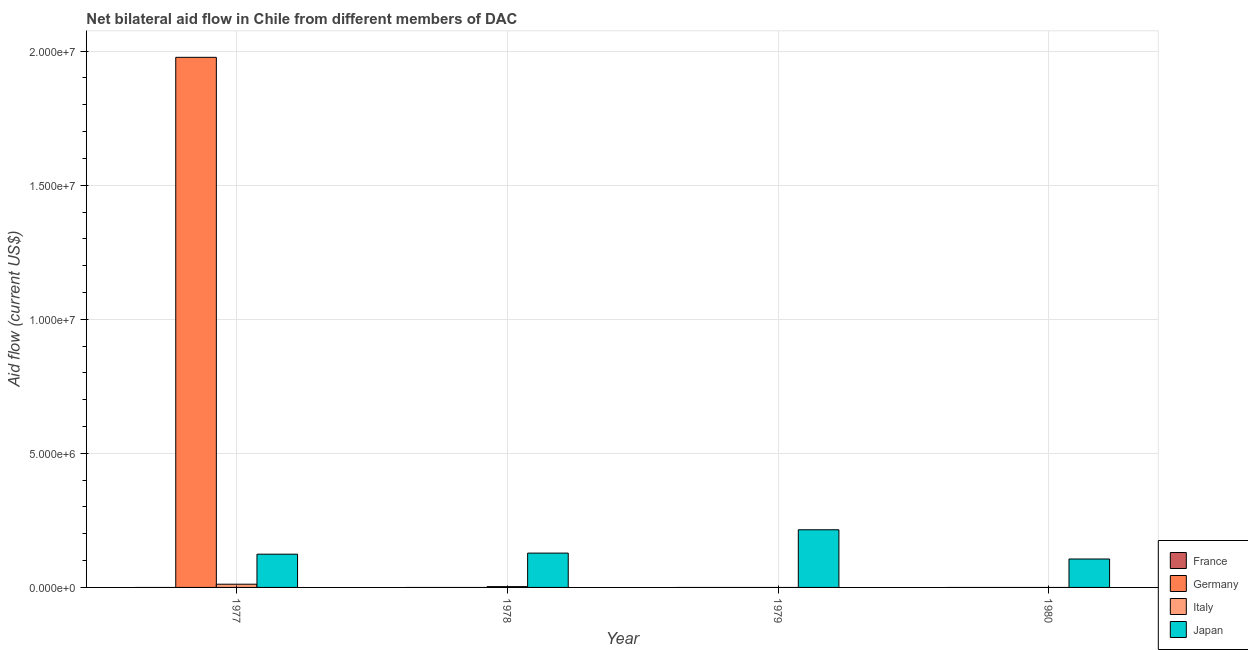How many different coloured bars are there?
Your answer should be compact. 3. Are the number of bars on each tick of the X-axis equal?
Make the answer very short. No. How many bars are there on the 1st tick from the left?
Keep it short and to the point. 3. In how many cases, is the number of bars for a given year not equal to the number of legend labels?
Your response must be concise. 4. What is the amount of aid given by italy in 1978?
Provide a succinct answer. 3.00e+04. Across all years, what is the maximum amount of aid given by italy?
Provide a short and direct response. 1.20e+05. Across all years, what is the minimum amount of aid given by germany?
Keep it short and to the point. 0. In which year was the amount of aid given by germany maximum?
Offer a terse response. 1977. What is the total amount of aid given by italy in the graph?
Make the answer very short. 1.50e+05. What is the difference between the amount of aid given by japan in 1979 and that in 1980?
Your answer should be very brief. 1.09e+06. What is the difference between the amount of aid given by france in 1977 and the amount of aid given by japan in 1978?
Ensure brevity in your answer.  0. What is the average amount of aid given by italy per year?
Ensure brevity in your answer.  3.75e+04. In how many years, is the amount of aid given by france greater than 14000000 US$?
Offer a very short reply. 0. What is the ratio of the amount of aid given by japan in 1978 to that in 1980?
Provide a succinct answer. 1.21. What is the difference between the highest and the second highest amount of aid given by japan?
Offer a very short reply. 8.70e+05. What is the difference between the highest and the lowest amount of aid given by italy?
Give a very brief answer. 1.20e+05. Is it the case that in every year, the sum of the amount of aid given by france and amount of aid given by germany is greater than the amount of aid given by italy?
Provide a short and direct response. No. How many bars are there?
Your answer should be very brief. 7. Are all the bars in the graph horizontal?
Provide a short and direct response. No. What is the difference between two consecutive major ticks on the Y-axis?
Give a very brief answer. 5.00e+06. Does the graph contain grids?
Your response must be concise. Yes. Where does the legend appear in the graph?
Your response must be concise. Bottom right. How many legend labels are there?
Your answer should be very brief. 4. How are the legend labels stacked?
Make the answer very short. Vertical. What is the title of the graph?
Ensure brevity in your answer.  Net bilateral aid flow in Chile from different members of DAC. Does "Portugal" appear as one of the legend labels in the graph?
Make the answer very short. No. What is the label or title of the X-axis?
Offer a very short reply. Year. What is the label or title of the Y-axis?
Make the answer very short. Aid flow (current US$). What is the Aid flow (current US$) in Germany in 1977?
Offer a terse response. 1.98e+07. What is the Aid flow (current US$) of Japan in 1977?
Your answer should be very brief. 1.24e+06. What is the Aid flow (current US$) in France in 1978?
Keep it short and to the point. 0. What is the Aid flow (current US$) of Italy in 1978?
Offer a terse response. 3.00e+04. What is the Aid flow (current US$) in Japan in 1978?
Your response must be concise. 1.28e+06. What is the Aid flow (current US$) in Germany in 1979?
Ensure brevity in your answer.  0. What is the Aid flow (current US$) in Japan in 1979?
Give a very brief answer. 2.15e+06. What is the Aid flow (current US$) in France in 1980?
Offer a terse response. 0. What is the Aid flow (current US$) in Germany in 1980?
Offer a terse response. 0. What is the Aid flow (current US$) in Japan in 1980?
Keep it short and to the point. 1.06e+06. Across all years, what is the maximum Aid flow (current US$) in Germany?
Your answer should be very brief. 1.98e+07. Across all years, what is the maximum Aid flow (current US$) of Japan?
Offer a very short reply. 2.15e+06. Across all years, what is the minimum Aid flow (current US$) in Italy?
Make the answer very short. 0. Across all years, what is the minimum Aid flow (current US$) in Japan?
Offer a terse response. 1.06e+06. What is the total Aid flow (current US$) in France in the graph?
Provide a short and direct response. 0. What is the total Aid flow (current US$) in Germany in the graph?
Make the answer very short. 1.98e+07. What is the total Aid flow (current US$) of Italy in the graph?
Your response must be concise. 1.50e+05. What is the total Aid flow (current US$) of Japan in the graph?
Offer a terse response. 5.73e+06. What is the difference between the Aid flow (current US$) of Italy in 1977 and that in 1978?
Your response must be concise. 9.00e+04. What is the difference between the Aid flow (current US$) in Japan in 1977 and that in 1979?
Provide a short and direct response. -9.10e+05. What is the difference between the Aid flow (current US$) of Japan in 1977 and that in 1980?
Your answer should be compact. 1.80e+05. What is the difference between the Aid flow (current US$) of Japan in 1978 and that in 1979?
Make the answer very short. -8.70e+05. What is the difference between the Aid flow (current US$) in Japan in 1979 and that in 1980?
Make the answer very short. 1.09e+06. What is the difference between the Aid flow (current US$) of Germany in 1977 and the Aid flow (current US$) of Italy in 1978?
Keep it short and to the point. 1.97e+07. What is the difference between the Aid flow (current US$) in Germany in 1977 and the Aid flow (current US$) in Japan in 1978?
Provide a short and direct response. 1.85e+07. What is the difference between the Aid flow (current US$) in Italy in 1977 and the Aid flow (current US$) in Japan in 1978?
Your answer should be very brief. -1.16e+06. What is the difference between the Aid flow (current US$) of Germany in 1977 and the Aid flow (current US$) of Japan in 1979?
Your response must be concise. 1.76e+07. What is the difference between the Aid flow (current US$) of Italy in 1977 and the Aid flow (current US$) of Japan in 1979?
Keep it short and to the point. -2.03e+06. What is the difference between the Aid flow (current US$) of Germany in 1977 and the Aid flow (current US$) of Japan in 1980?
Provide a succinct answer. 1.87e+07. What is the difference between the Aid flow (current US$) of Italy in 1977 and the Aid flow (current US$) of Japan in 1980?
Your answer should be very brief. -9.40e+05. What is the difference between the Aid flow (current US$) of Italy in 1978 and the Aid flow (current US$) of Japan in 1979?
Give a very brief answer. -2.12e+06. What is the difference between the Aid flow (current US$) in Italy in 1978 and the Aid flow (current US$) in Japan in 1980?
Provide a short and direct response. -1.03e+06. What is the average Aid flow (current US$) of France per year?
Give a very brief answer. 0. What is the average Aid flow (current US$) in Germany per year?
Keep it short and to the point. 4.94e+06. What is the average Aid flow (current US$) of Italy per year?
Your answer should be compact. 3.75e+04. What is the average Aid flow (current US$) in Japan per year?
Give a very brief answer. 1.43e+06. In the year 1977, what is the difference between the Aid flow (current US$) in Germany and Aid flow (current US$) in Italy?
Provide a succinct answer. 1.96e+07. In the year 1977, what is the difference between the Aid flow (current US$) of Germany and Aid flow (current US$) of Japan?
Keep it short and to the point. 1.85e+07. In the year 1977, what is the difference between the Aid flow (current US$) in Italy and Aid flow (current US$) in Japan?
Your answer should be very brief. -1.12e+06. In the year 1978, what is the difference between the Aid flow (current US$) of Italy and Aid flow (current US$) of Japan?
Provide a short and direct response. -1.25e+06. What is the ratio of the Aid flow (current US$) of Italy in 1977 to that in 1978?
Your answer should be very brief. 4. What is the ratio of the Aid flow (current US$) of Japan in 1977 to that in 1978?
Your answer should be very brief. 0.97. What is the ratio of the Aid flow (current US$) in Japan in 1977 to that in 1979?
Keep it short and to the point. 0.58. What is the ratio of the Aid flow (current US$) of Japan in 1977 to that in 1980?
Your response must be concise. 1.17. What is the ratio of the Aid flow (current US$) in Japan in 1978 to that in 1979?
Provide a short and direct response. 0.6. What is the ratio of the Aid flow (current US$) of Japan in 1978 to that in 1980?
Offer a very short reply. 1.21. What is the ratio of the Aid flow (current US$) of Japan in 1979 to that in 1980?
Make the answer very short. 2.03. What is the difference between the highest and the second highest Aid flow (current US$) in Japan?
Offer a terse response. 8.70e+05. What is the difference between the highest and the lowest Aid flow (current US$) of Germany?
Offer a very short reply. 1.98e+07. What is the difference between the highest and the lowest Aid flow (current US$) in Italy?
Ensure brevity in your answer.  1.20e+05. What is the difference between the highest and the lowest Aid flow (current US$) in Japan?
Ensure brevity in your answer.  1.09e+06. 